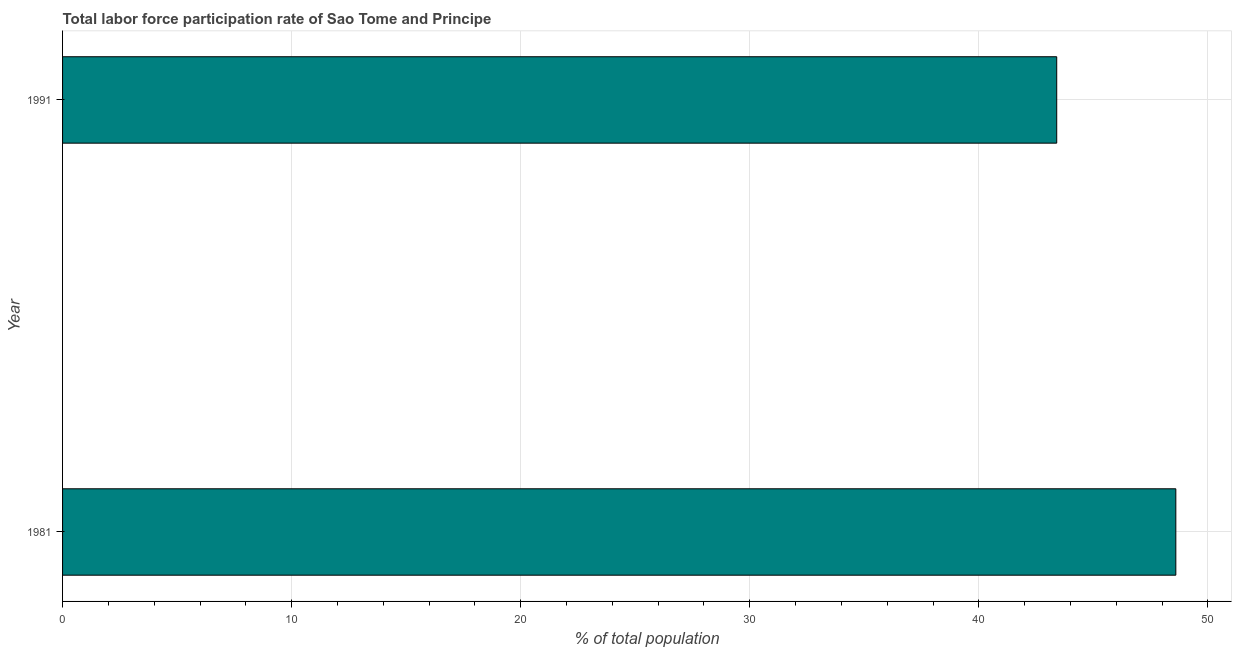Does the graph contain grids?
Your answer should be compact. Yes. What is the title of the graph?
Offer a terse response. Total labor force participation rate of Sao Tome and Principe. What is the label or title of the X-axis?
Provide a succinct answer. % of total population. What is the label or title of the Y-axis?
Offer a very short reply. Year. What is the total labor force participation rate in 1981?
Make the answer very short. 48.6. Across all years, what is the maximum total labor force participation rate?
Offer a very short reply. 48.6. Across all years, what is the minimum total labor force participation rate?
Your response must be concise. 43.4. In which year was the total labor force participation rate minimum?
Your answer should be very brief. 1991. What is the sum of the total labor force participation rate?
Keep it short and to the point. 92. Do a majority of the years between 1991 and 1981 (inclusive) have total labor force participation rate greater than 4 %?
Provide a short and direct response. No. What is the ratio of the total labor force participation rate in 1981 to that in 1991?
Your response must be concise. 1.12. Is the total labor force participation rate in 1981 less than that in 1991?
Ensure brevity in your answer.  No. In how many years, is the total labor force participation rate greater than the average total labor force participation rate taken over all years?
Ensure brevity in your answer.  1. How many bars are there?
Your response must be concise. 2. Are all the bars in the graph horizontal?
Give a very brief answer. Yes. How many years are there in the graph?
Keep it short and to the point. 2. What is the % of total population in 1981?
Your response must be concise. 48.6. What is the % of total population in 1991?
Your answer should be compact. 43.4. What is the difference between the % of total population in 1981 and 1991?
Provide a short and direct response. 5.2. What is the ratio of the % of total population in 1981 to that in 1991?
Offer a very short reply. 1.12. 